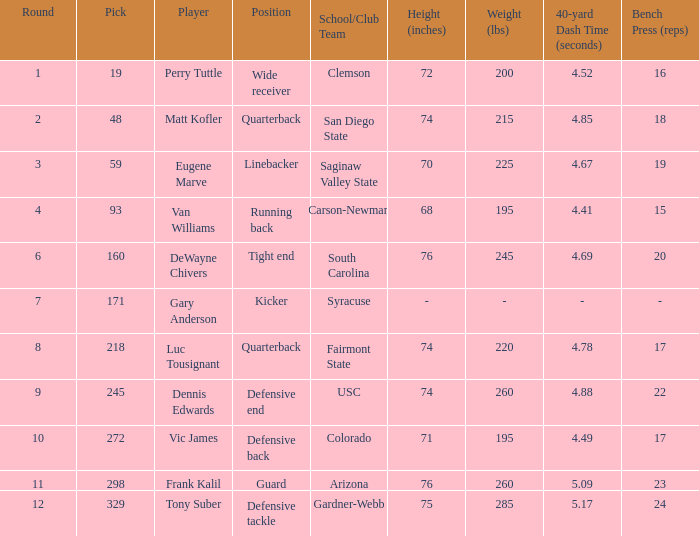Who plays linebacker? Eugene Marve. 